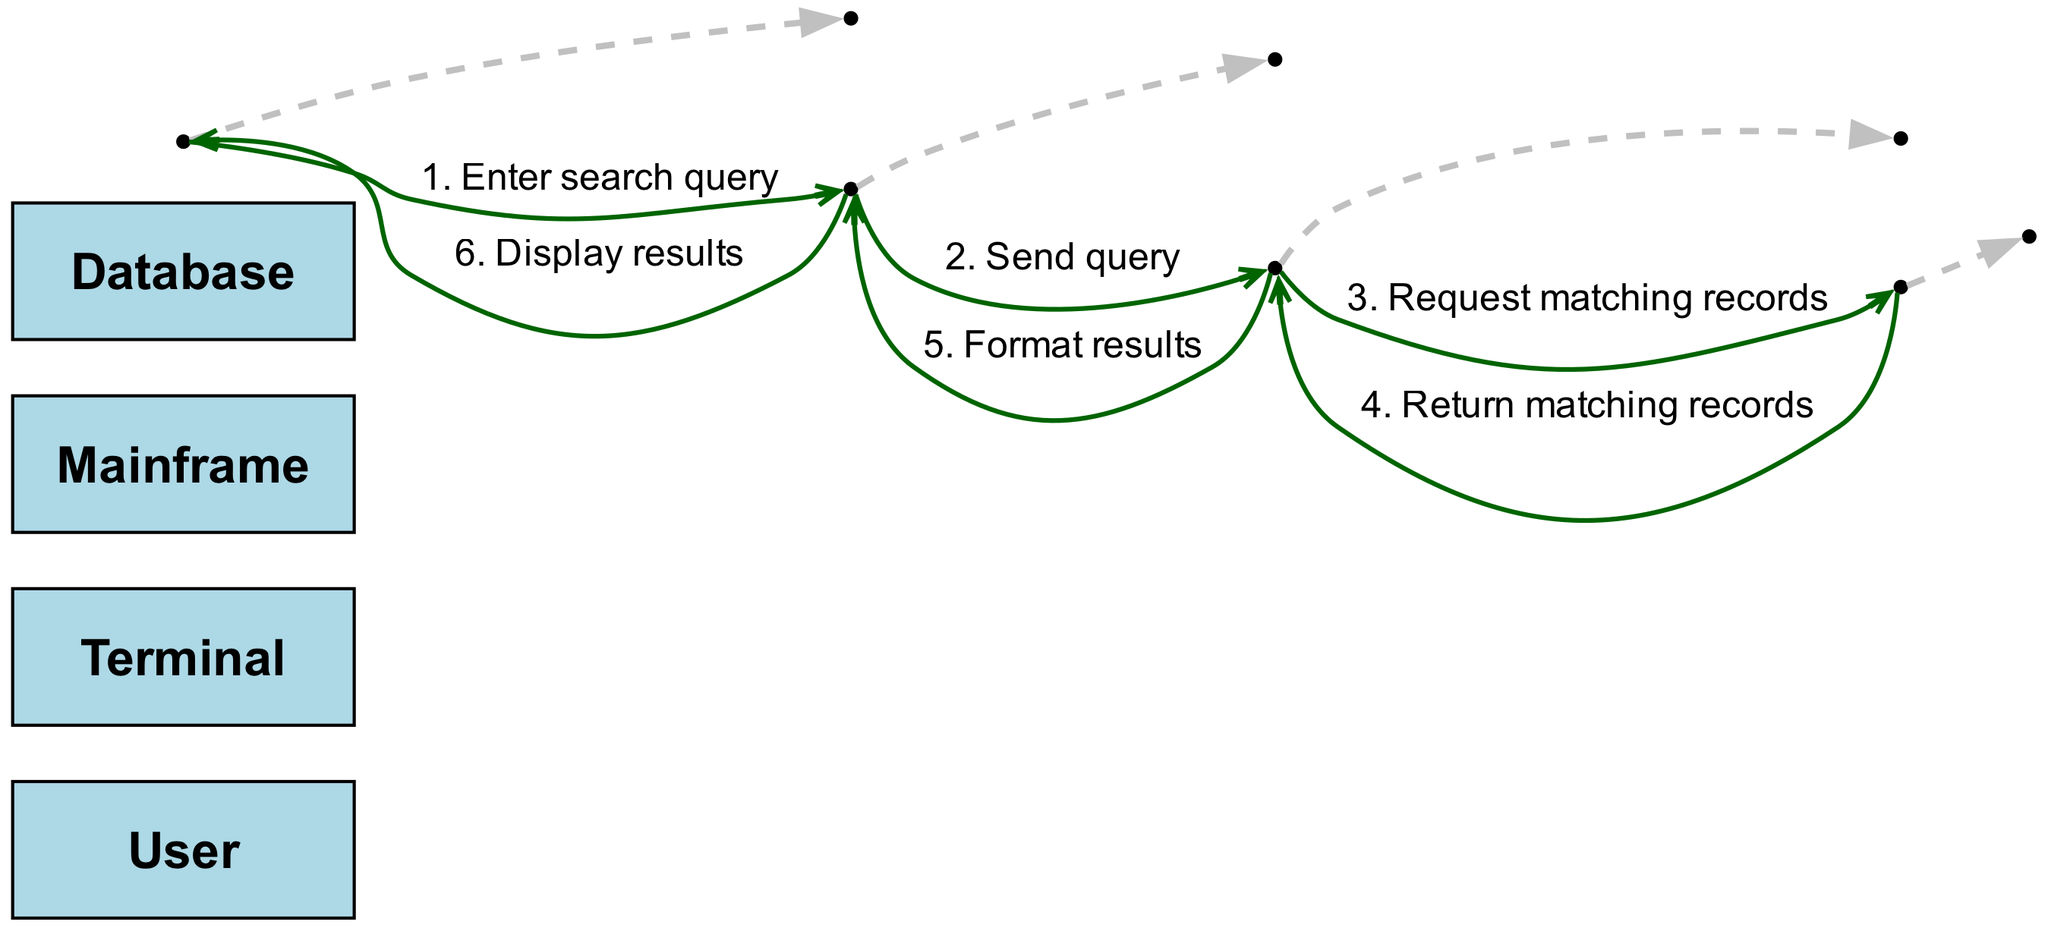What is the first action taken by the user? The first action taken by the user, as depicted in the diagram, is to "Enter search query" into the terminal. This is the initial step in the sequence.
Answer: Enter search query How many actors are involved in this sequence diagram? The sequence diagram includes four actors: User, Terminal, Mainframe, and Database. Counting each distinct actor gives us a total of four.
Answer: Four What message is sent from the Terminal to the Mainframe? According to the diagram, the message sent from the Terminal to the Mainframe is "Send query". This is the second message in the sequence.
Answer: Send query Which actor returns matching records and to whom? The actor that returns matching records is the Database, and it sends these records back to the Mainframe, as indicated by the flow of messages in the diagram.
Answer: Mainframe Identify the third message in the sequence. The third message, as shown in the sequence, is "Request matching records", which is sent from the Mainframe to the Database, following the previous messages.
Answer: Request matching records What happens after the Mainframe formats the results? After the Mainframe formats the results, it sends the formatted output to the Terminal, which then displays the results to the User. This step is a continuation of the data retrieval process depicted in the diagram.
Answer: Display results Which two actors are involved in the last action of the sequence? The last action in the sequence involves two actors: the Terminal and the User. The Terminal displays the results to the User, concluding the sequence of actions.
Answer: Terminal and User What type of messages are represented by the arrows in the sequence diagram? The messages represented by the arrows in the sequence diagram are actions or communications exchanged between the actors involved in the data retrieval process. Each arrow indicates the flow of information in the sequence.
Answer: Actions or communications Which actor initially receives the input? The initial input in the sequence is received by the Terminal from the User, who enters a search query. This is the starting point of the entire process.
Answer: Terminal 